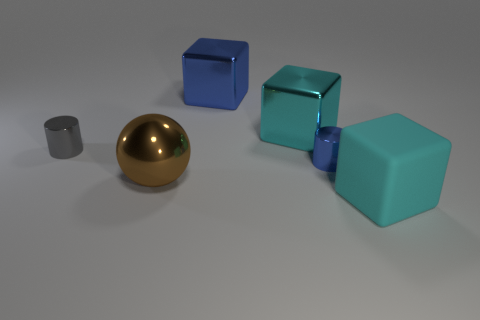Do the cyan matte object and the blue thing to the right of the blue cube have the same shape?
Provide a succinct answer. No. How many blue things are on the left side of the blue shiny cylinder and in front of the big blue metal object?
Your answer should be compact. 0. Is the material of the large ball the same as the blue object behind the gray metallic thing?
Provide a succinct answer. Yes. Are there the same number of small cylinders in front of the small blue cylinder and small metallic cylinders?
Provide a succinct answer. No. What is the color of the small object right of the large blue thing?
Your answer should be compact. Blue. How many other things are the same color as the metallic ball?
Keep it short and to the point. 0. Is there anything else that has the same size as the blue cylinder?
Your answer should be very brief. Yes. There is a cylinder that is left of the ball; is its size the same as the large ball?
Ensure brevity in your answer.  No. There is a big cube that is in front of the big ball; what is its material?
Offer a very short reply. Rubber. Are there any other things that are the same shape as the big cyan rubber thing?
Your response must be concise. Yes. 